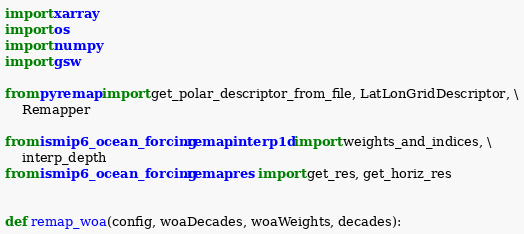Convert code to text. <code><loc_0><loc_0><loc_500><loc_500><_Python_>import xarray
import os
import numpy
import gsw

from pyremap import get_polar_descriptor_from_file, LatLonGridDescriptor, \
    Remapper

from ismip6_ocean_forcing.remap.interp1d import weights_and_indices, \
    interp_depth
from ismip6_ocean_forcing.remap.res import get_res, get_horiz_res


def remap_woa(config, woaDecades, woaWeights, decades):</code> 